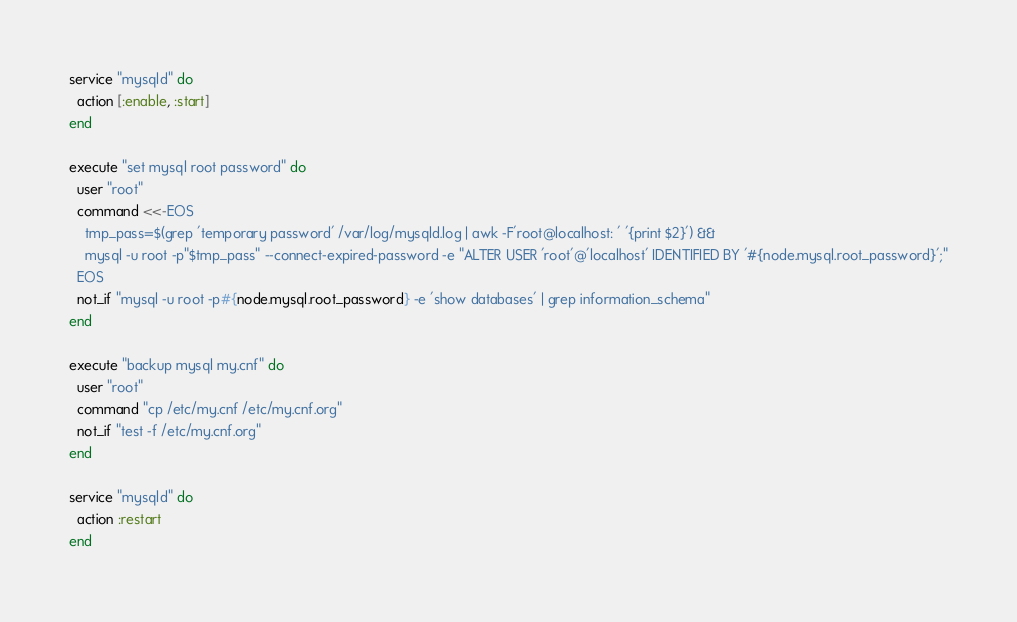<code> <loc_0><loc_0><loc_500><loc_500><_Ruby_>
service "mysqld" do
  action [:enable, :start]
end

execute "set mysql root password" do
  user "root"
  command <<-EOS
    tmp_pass=$(grep 'temporary password' /var/log/mysqld.log | awk -F'root@localhost: ' '{print $2}') &&
    mysql -u root -p"$tmp_pass" --connect-expired-password -e "ALTER USER 'root'@'localhost' IDENTIFIED BY '#{node.mysql.root_password}';"
  EOS
  not_if "mysql -u root -p#{node.mysql.root_password} -e 'show databases' | grep information_schema"
end

execute "backup mysql my.cnf" do
  user "root"
  command "cp /etc/my.cnf /etc/my.cnf.org"
  not_if "test -f /etc/my.cnf.org"
end

service "mysqld" do
  action :restart
end
</code> 